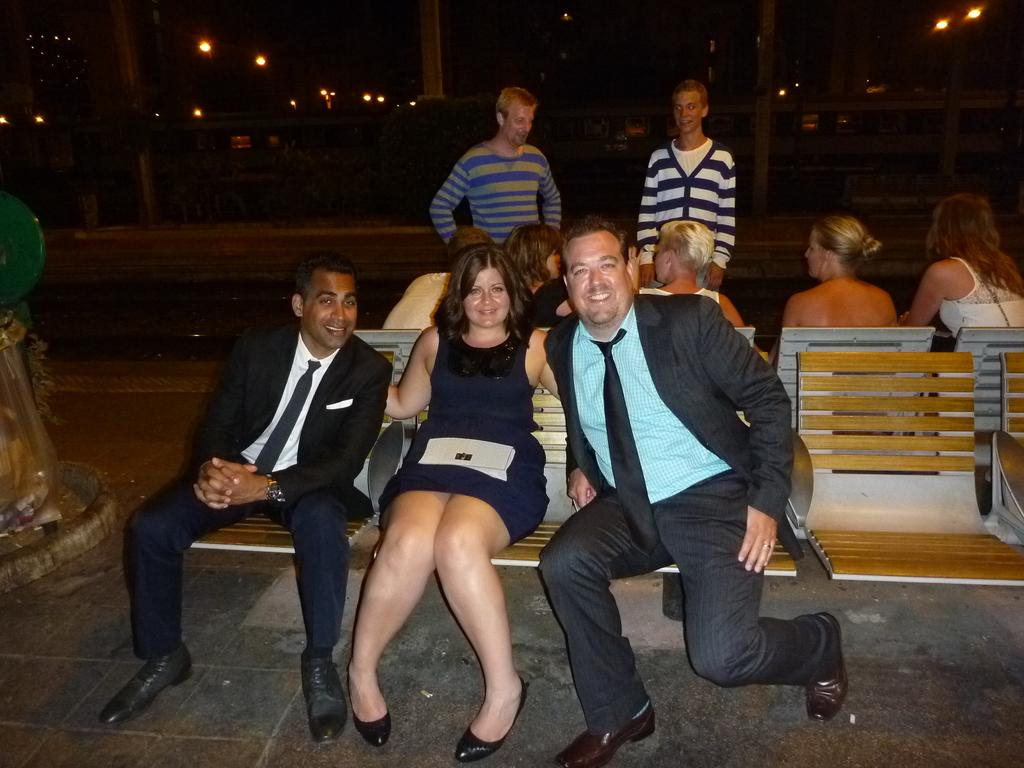What are the people in the image doing? There is a group of people sitting on chairs in the image. Are there any people standing in the image? Yes, there are two people standing in the image. What can be seen in the background of the image? There is a road visible in the image. What else can be seen in the image besides the people and road? There are plants and lights in the image. What type of pies are being served to the people in the image? There is no mention of pies in the image; it only shows people sitting and standing, a road, plants, and lights. 